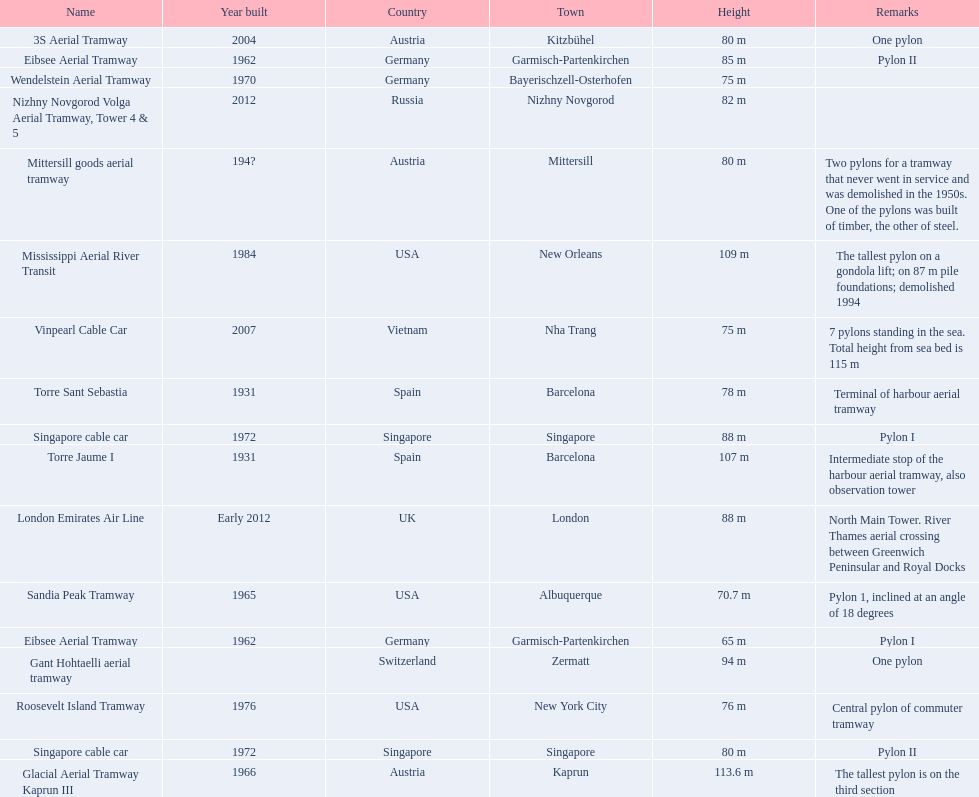List two pylons that are at most, 80 m in height. Mittersill goods aerial tramway, Singapore cable car. 